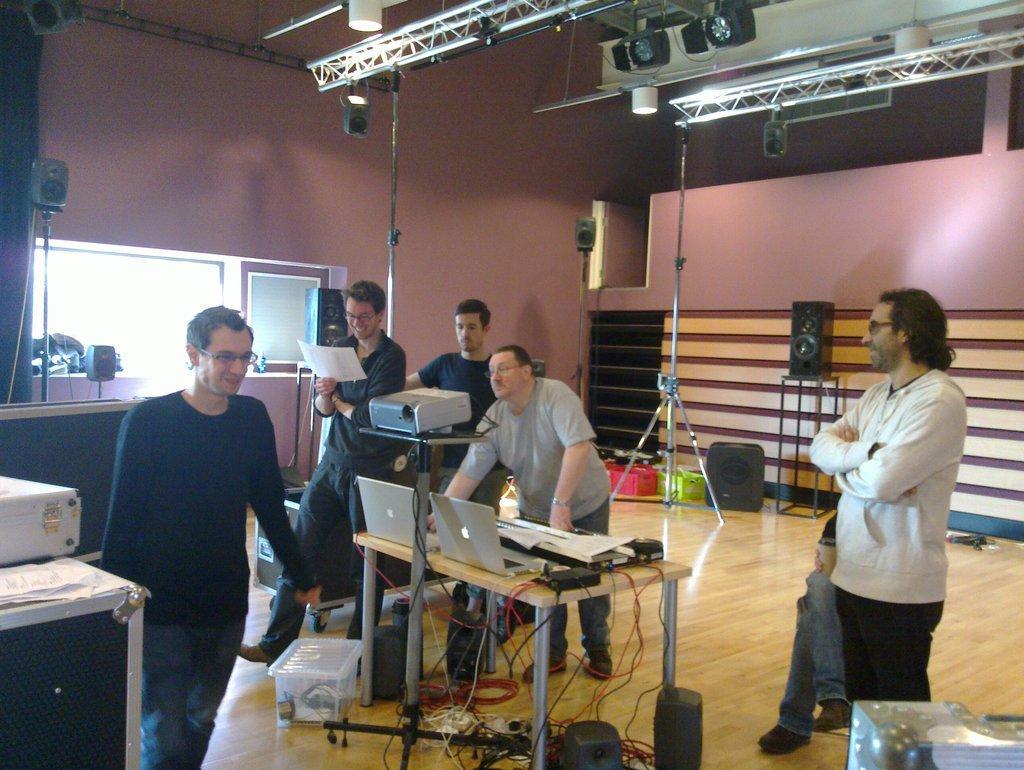Please provide a concise description of this image. In this image we can see persons, laptops, tables, wires, projector, speakers, lights, windows, stands, wall, papers and tube light. 